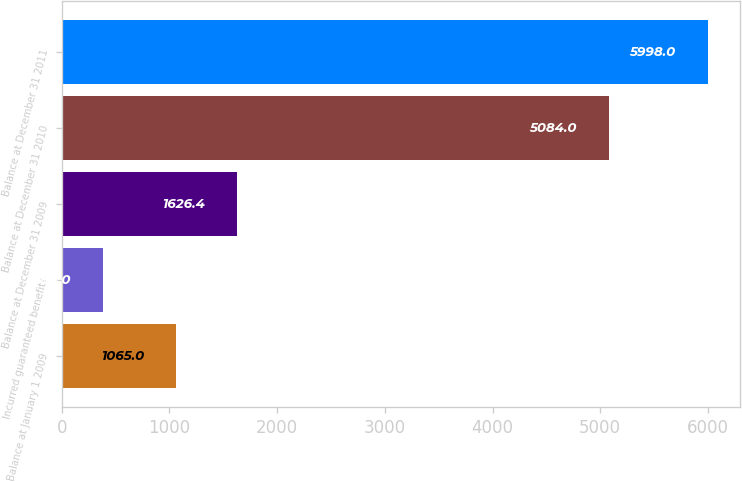Convert chart to OTSL. <chart><loc_0><loc_0><loc_500><loc_500><bar_chart><fcel>Balance at January 1 2009<fcel>Incurred guaranteed benefits<fcel>Balance at December 31 2009<fcel>Balance at December 31 2010<fcel>Balance at December 31 2011<nl><fcel>1065<fcel>384<fcel>1626.4<fcel>5084<fcel>5998<nl></chart> 